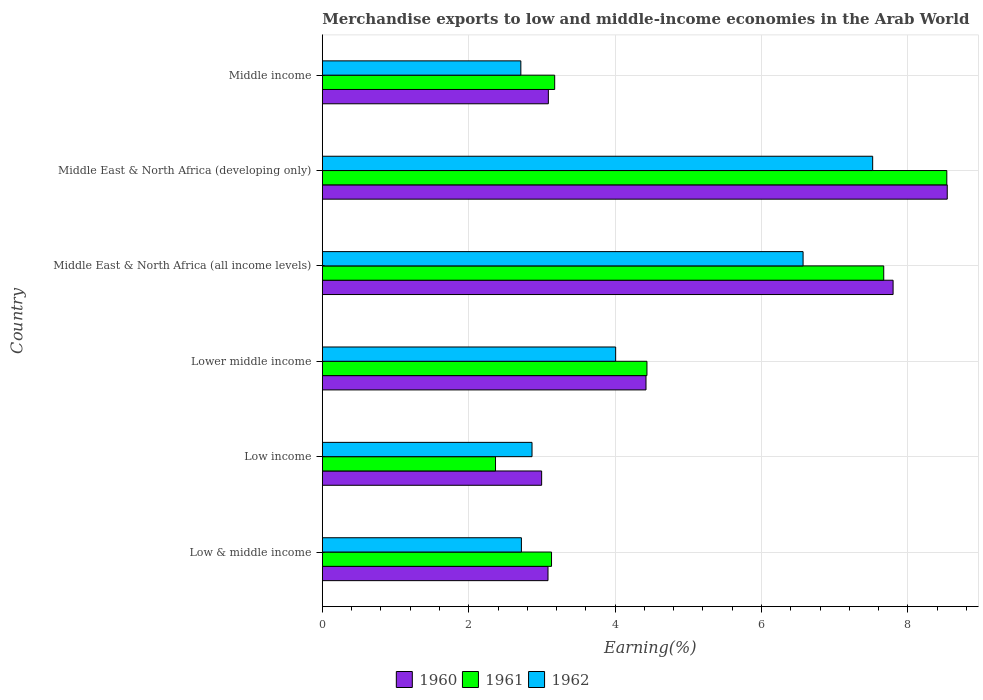Are the number of bars per tick equal to the number of legend labels?
Offer a terse response. Yes. Are the number of bars on each tick of the Y-axis equal?
Your answer should be compact. Yes. How many bars are there on the 3rd tick from the top?
Your answer should be compact. 3. What is the label of the 6th group of bars from the top?
Provide a succinct answer. Low & middle income. In how many cases, is the number of bars for a given country not equal to the number of legend labels?
Your answer should be very brief. 0. What is the percentage of amount earned from merchandise exports in 1960 in Middle income?
Make the answer very short. 3.09. Across all countries, what is the maximum percentage of amount earned from merchandise exports in 1962?
Your answer should be very brief. 7.52. Across all countries, what is the minimum percentage of amount earned from merchandise exports in 1960?
Make the answer very short. 3. In which country was the percentage of amount earned from merchandise exports in 1962 maximum?
Give a very brief answer. Middle East & North Africa (developing only). What is the total percentage of amount earned from merchandise exports in 1962 in the graph?
Provide a succinct answer. 26.39. What is the difference between the percentage of amount earned from merchandise exports in 1960 in Middle East & North Africa (all income levels) and that in Middle East & North Africa (developing only)?
Make the answer very short. -0.74. What is the difference between the percentage of amount earned from merchandise exports in 1961 in Low & middle income and the percentage of amount earned from merchandise exports in 1962 in Low income?
Ensure brevity in your answer.  0.27. What is the average percentage of amount earned from merchandise exports in 1960 per country?
Your answer should be very brief. 4.99. What is the difference between the percentage of amount earned from merchandise exports in 1962 and percentage of amount earned from merchandise exports in 1961 in Middle East & North Africa (developing only)?
Give a very brief answer. -1.01. In how many countries, is the percentage of amount earned from merchandise exports in 1961 greater than 4.4 %?
Offer a terse response. 3. What is the ratio of the percentage of amount earned from merchandise exports in 1961 in Low income to that in Middle East & North Africa (developing only)?
Give a very brief answer. 0.28. Is the percentage of amount earned from merchandise exports in 1961 in Low income less than that in Lower middle income?
Provide a succinct answer. Yes. What is the difference between the highest and the second highest percentage of amount earned from merchandise exports in 1961?
Offer a very short reply. 0.86. What is the difference between the highest and the lowest percentage of amount earned from merchandise exports in 1962?
Provide a short and direct response. 4.81. What does the 2nd bar from the bottom in Middle East & North Africa (developing only) represents?
Make the answer very short. 1961. Is it the case that in every country, the sum of the percentage of amount earned from merchandise exports in 1962 and percentage of amount earned from merchandise exports in 1961 is greater than the percentage of amount earned from merchandise exports in 1960?
Give a very brief answer. Yes. Are all the bars in the graph horizontal?
Keep it short and to the point. Yes. How many countries are there in the graph?
Keep it short and to the point. 6. Are the values on the major ticks of X-axis written in scientific E-notation?
Give a very brief answer. No. How many legend labels are there?
Give a very brief answer. 3. How are the legend labels stacked?
Offer a terse response. Horizontal. What is the title of the graph?
Make the answer very short. Merchandise exports to low and middle-income economies in the Arab World. Does "1982" appear as one of the legend labels in the graph?
Give a very brief answer. No. What is the label or title of the X-axis?
Your response must be concise. Earning(%). What is the Earning(%) in 1960 in Low & middle income?
Make the answer very short. 3.08. What is the Earning(%) of 1961 in Low & middle income?
Make the answer very short. 3.13. What is the Earning(%) in 1962 in Low & middle income?
Give a very brief answer. 2.72. What is the Earning(%) of 1960 in Low income?
Your answer should be very brief. 3. What is the Earning(%) of 1961 in Low income?
Offer a very short reply. 2.37. What is the Earning(%) in 1962 in Low income?
Provide a succinct answer. 2.86. What is the Earning(%) of 1960 in Lower middle income?
Your response must be concise. 4.42. What is the Earning(%) of 1961 in Lower middle income?
Your response must be concise. 4.43. What is the Earning(%) of 1962 in Lower middle income?
Offer a very short reply. 4.01. What is the Earning(%) in 1960 in Middle East & North Africa (all income levels)?
Provide a short and direct response. 7.8. What is the Earning(%) of 1961 in Middle East & North Africa (all income levels)?
Give a very brief answer. 7.67. What is the Earning(%) in 1962 in Middle East & North Africa (all income levels)?
Offer a very short reply. 6.57. What is the Earning(%) in 1960 in Middle East & North Africa (developing only)?
Your answer should be compact. 8.54. What is the Earning(%) in 1961 in Middle East & North Africa (developing only)?
Offer a very short reply. 8.53. What is the Earning(%) of 1962 in Middle East & North Africa (developing only)?
Offer a terse response. 7.52. What is the Earning(%) of 1960 in Middle income?
Your answer should be very brief. 3.09. What is the Earning(%) in 1961 in Middle income?
Give a very brief answer. 3.17. What is the Earning(%) of 1962 in Middle income?
Offer a terse response. 2.71. Across all countries, what is the maximum Earning(%) of 1960?
Offer a very short reply. 8.54. Across all countries, what is the maximum Earning(%) of 1961?
Give a very brief answer. 8.53. Across all countries, what is the maximum Earning(%) in 1962?
Keep it short and to the point. 7.52. Across all countries, what is the minimum Earning(%) in 1960?
Offer a very short reply. 3. Across all countries, what is the minimum Earning(%) in 1961?
Make the answer very short. 2.37. Across all countries, what is the minimum Earning(%) in 1962?
Keep it short and to the point. 2.71. What is the total Earning(%) of 1960 in the graph?
Keep it short and to the point. 29.92. What is the total Earning(%) of 1961 in the graph?
Keep it short and to the point. 29.31. What is the total Earning(%) of 1962 in the graph?
Your answer should be compact. 26.39. What is the difference between the Earning(%) in 1960 in Low & middle income and that in Low income?
Your answer should be compact. 0.09. What is the difference between the Earning(%) in 1961 in Low & middle income and that in Low income?
Your response must be concise. 0.77. What is the difference between the Earning(%) in 1962 in Low & middle income and that in Low income?
Your answer should be very brief. -0.14. What is the difference between the Earning(%) in 1960 in Low & middle income and that in Lower middle income?
Keep it short and to the point. -1.34. What is the difference between the Earning(%) of 1961 in Low & middle income and that in Lower middle income?
Offer a terse response. -1.3. What is the difference between the Earning(%) in 1962 in Low & middle income and that in Lower middle income?
Provide a short and direct response. -1.29. What is the difference between the Earning(%) in 1960 in Low & middle income and that in Middle East & North Africa (all income levels)?
Make the answer very short. -4.71. What is the difference between the Earning(%) in 1961 in Low & middle income and that in Middle East & North Africa (all income levels)?
Your answer should be very brief. -4.54. What is the difference between the Earning(%) in 1962 in Low & middle income and that in Middle East & North Africa (all income levels)?
Ensure brevity in your answer.  -3.85. What is the difference between the Earning(%) in 1960 in Low & middle income and that in Middle East & North Africa (developing only)?
Keep it short and to the point. -5.45. What is the difference between the Earning(%) of 1961 in Low & middle income and that in Middle East & North Africa (developing only)?
Provide a short and direct response. -5.4. What is the difference between the Earning(%) of 1962 in Low & middle income and that in Middle East & North Africa (developing only)?
Make the answer very short. -4.8. What is the difference between the Earning(%) in 1960 in Low & middle income and that in Middle income?
Ensure brevity in your answer.  -0. What is the difference between the Earning(%) in 1961 in Low & middle income and that in Middle income?
Keep it short and to the point. -0.04. What is the difference between the Earning(%) of 1962 in Low & middle income and that in Middle income?
Give a very brief answer. 0.01. What is the difference between the Earning(%) in 1960 in Low income and that in Lower middle income?
Give a very brief answer. -1.43. What is the difference between the Earning(%) of 1961 in Low income and that in Lower middle income?
Provide a succinct answer. -2.07. What is the difference between the Earning(%) of 1962 in Low income and that in Lower middle income?
Provide a short and direct response. -1.14. What is the difference between the Earning(%) in 1960 in Low income and that in Middle East & North Africa (all income levels)?
Offer a terse response. -4.8. What is the difference between the Earning(%) of 1961 in Low income and that in Middle East & North Africa (all income levels)?
Your response must be concise. -5.3. What is the difference between the Earning(%) in 1962 in Low income and that in Middle East & North Africa (all income levels)?
Make the answer very short. -3.7. What is the difference between the Earning(%) in 1960 in Low income and that in Middle East & North Africa (developing only)?
Keep it short and to the point. -5.54. What is the difference between the Earning(%) in 1961 in Low income and that in Middle East & North Africa (developing only)?
Provide a short and direct response. -6.17. What is the difference between the Earning(%) in 1962 in Low income and that in Middle East & North Africa (developing only)?
Your answer should be compact. -4.65. What is the difference between the Earning(%) of 1960 in Low income and that in Middle income?
Offer a terse response. -0.09. What is the difference between the Earning(%) of 1961 in Low income and that in Middle income?
Offer a terse response. -0.81. What is the difference between the Earning(%) of 1962 in Low income and that in Middle income?
Provide a short and direct response. 0.15. What is the difference between the Earning(%) of 1960 in Lower middle income and that in Middle East & North Africa (all income levels)?
Offer a terse response. -3.38. What is the difference between the Earning(%) in 1961 in Lower middle income and that in Middle East & North Africa (all income levels)?
Make the answer very short. -3.23. What is the difference between the Earning(%) in 1962 in Lower middle income and that in Middle East & North Africa (all income levels)?
Your response must be concise. -2.56. What is the difference between the Earning(%) in 1960 in Lower middle income and that in Middle East & North Africa (developing only)?
Your answer should be compact. -4.12. What is the difference between the Earning(%) in 1961 in Lower middle income and that in Middle East & North Africa (developing only)?
Your response must be concise. -4.1. What is the difference between the Earning(%) of 1962 in Lower middle income and that in Middle East & North Africa (developing only)?
Your answer should be very brief. -3.51. What is the difference between the Earning(%) of 1960 in Lower middle income and that in Middle income?
Give a very brief answer. 1.33. What is the difference between the Earning(%) in 1961 in Lower middle income and that in Middle income?
Your response must be concise. 1.26. What is the difference between the Earning(%) in 1962 in Lower middle income and that in Middle income?
Provide a succinct answer. 1.3. What is the difference between the Earning(%) in 1960 in Middle East & North Africa (all income levels) and that in Middle East & North Africa (developing only)?
Your answer should be compact. -0.74. What is the difference between the Earning(%) in 1961 in Middle East & North Africa (all income levels) and that in Middle East & North Africa (developing only)?
Offer a terse response. -0.86. What is the difference between the Earning(%) of 1962 in Middle East & North Africa (all income levels) and that in Middle East & North Africa (developing only)?
Your answer should be compact. -0.95. What is the difference between the Earning(%) in 1960 in Middle East & North Africa (all income levels) and that in Middle income?
Provide a short and direct response. 4.71. What is the difference between the Earning(%) of 1961 in Middle East & North Africa (all income levels) and that in Middle income?
Offer a very short reply. 4.5. What is the difference between the Earning(%) of 1962 in Middle East & North Africa (all income levels) and that in Middle income?
Provide a short and direct response. 3.86. What is the difference between the Earning(%) of 1960 in Middle East & North Africa (developing only) and that in Middle income?
Your answer should be compact. 5.45. What is the difference between the Earning(%) in 1961 in Middle East & North Africa (developing only) and that in Middle income?
Make the answer very short. 5.36. What is the difference between the Earning(%) in 1962 in Middle East & North Africa (developing only) and that in Middle income?
Your answer should be compact. 4.81. What is the difference between the Earning(%) of 1960 in Low & middle income and the Earning(%) of 1961 in Low income?
Your answer should be very brief. 0.72. What is the difference between the Earning(%) of 1960 in Low & middle income and the Earning(%) of 1962 in Low income?
Make the answer very short. 0.22. What is the difference between the Earning(%) in 1961 in Low & middle income and the Earning(%) in 1962 in Low income?
Make the answer very short. 0.27. What is the difference between the Earning(%) of 1960 in Low & middle income and the Earning(%) of 1961 in Lower middle income?
Offer a very short reply. -1.35. What is the difference between the Earning(%) in 1960 in Low & middle income and the Earning(%) in 1962 in Lower middle income?
Offer a very short reply. -0.92. What is the difference between the Earning(%) of 1961 in Low & middle income and the Earning(%) of 1962 in Lower middle income?
Offer a very short reply. -0.88. What is the difference between the Earning(%) in 1960 in Low & middle income and the Earning(%) in 1961 in Middle East & North Africa (all income levels)?
Your answer should be compact. -4.59. What is the difference between the Earning(%) in 1960 in Low & middle income and the Earning(%) in 1962 in Middle East & North Africa (all income levels)?
Ensure brevity in your answer.  -3.48. What is the difference between the Earning(%) in 1961 in Low & middle income and the Earning(%) in 1962 in Middle East & North Africa (all income levels)?
Give a very brief answer. -3.44. What is the difference between the Earning(%) in 1960 in Low & middle income and the Earning(%) in 1961 in Middle East & North Africa (developing only)?
Give a very brief answer. -5.45. What is the difference between the Earning(%) in 1960 in Low & middle income and the Earning(%) in 1962 in Middle East & North Africa (developing only)?
Make the answer very short. -4.44. What is the difference between the Earning(%) of 1961 in Low & middle income and the Earning(%) of 1962 in Middle East & North Africa (developing only)?
Make the answer very short. -4.39. What is the difference between the Earning(%) of 1960 in Low & middle income and the Earning(%) of 1961 in Middle income?
Give a very brief answer. -0.09. What is the difference between the Earning(%) in 1960 in Low & middle income and the Earning(%) in 1962 in Middle income?
Your answer should be compact. 0.37. What is the difference between the Earning(%) of 1961 in Low & middle income and the Earning(%) of 1962 in Middle income?
Make the answer very short. 0.42. What is the difference between the Earning(%) of 1960 in Low income and the Earning(%) of 1961 in Lower middle income?
Keep it short and to the point. -1.44. What is the difference between the Earning(%) of 1960 in Low income and the Earning(%) of 1962 in Lower middle income?
Your answer should be very brief. -1.01. What is the difference between the Earning(%) of 1961 in Low income and the Earning(%) of 1962 in Lower middle income?
Offer a very short reply. -1.64. What is the difference between the Earning(%) of 1960 in Low income and the Earning(%) of 1961 in Middle East & North Africa (all income levels)?
Your answer should be compact. -4.67. What is the difference between the Earning(%) of 1960 in Low income and the Earning(%) of 1962 in Middle East & North Africa (all income levels)?
Keep it short and to the point. -3.57. What is the difference between the Earning(%) in 1961 in Low income and the Earning(%) in 1962 in Middle East & North Africa (all income levels)?
Give a very brief answer. -4.2. What is the difference between the Earning(%) in 1960 in Low income and the Earning(%) in 1961 in Middle East & North Africa (developing only)?
Provide a succinct answer. -5.54. What is the difference between the Earning(%) of 1960 in Low income and the Earning(%) of 1962 in Middle East & North Africa (developing only)?
Offer a terse response. -4.52. What is the difference between the Earning(%) of 1961 in Low income and the Earning(%) of 1962 in Middle East & North Africa (developing only)?
Give a very brief answer. -5.15. What is the difference between the Earning(%) in 1960 in Low income and the Earning(%) in 1961 in Middle income?
Your answer should be very brief. -0.18. What is the difference between the Earning(%) in 1960 in Low income and the Earning(%) in 1962 in Middle income?
Provide a short and direct response. 0.28. What is the difference between the Earning(%) of 1961 in Low income and the Earning(%) of 1962 in Middle income?
Provide a short and direct response. -0.35. What is the difference between the Earning(%) of 1960 in Lower middle income and the Earning(%) of 1961 in Middle East & North Africa (all income levels)?
Keep it short and to the point. -3.25. What is the difference between the Earning(%) in 1960 in Lower middle income and the Earning(%) in 1962 in Middle East & North Africa (all income levels)?
Keep it short and to the point. -2.15. What is the difference between the Earning(%) of 1961 in Lower middle income and the Earning(%) of 1962 in Middle East & North Africa (all income levels)?
Ensure brevity in your answer.  -2.13. What is the difference between the Earning(%) of 1960 in Lower middle income and the Earning(%) of 1961 in Middle East & North Africa (developing only)?
Your answer should be compact. -4.11. What is the difference between the Earning(%) of 1960 in Lower middle income and the Earning(%) of 1962 in Middle East & North Africa (developing only)?
Your answer should be compact. -3.1. What is the difference between the Earning(%) of 1961 in Lower middle income and the Earning(%) of 1962 in Middle East & North Africa (developing only)?
Give a very brief answer. -3.08. What is the difference between the Earning(%) in 1960 in Lower middle income and the Earning(%) in 1961 in Middle income?
Your answer should be compact. 1.25. What is the difference between the Earning(%) in 1960 in Lower middle income and the Earning(%) in 1962 in Middle income?
Offer a very short reply. 1.71. What is the difference between the Earning(%) of 1961 in Lower middle income and the Earning(%) of 1962 in Middle income?
Offer a very short reply. 1.72. What is the difference between the Earning(%) in 1960 in Middle East & North Africa (all income levels) and the Earning(%) in 1961 in Middle East & North Africa (developing only)?
Offer a very short reply. -0.73. What is the difference between the Earning(%) in 1960 in Middle East & North Africa (all income levels) and the Earning(%) in 1962 in Middle East & North Africa (developing only)?
Offer a terse response. 0.28. What is the difference between the Earning(%) in 1961 in Middle East & North Africa (all income levels) and the Earning(%) in 1962 in Middle East & North Africa (developing only)?
Provide a succinct answer. 0.15. What is the difference between the Earning(%) in 1960 in Middle East & North Africa (all income levels) and the Earning(%) in 1961 in Middle income?
Give a very brief answer. 4.62. What is the difference between the Earning(%) in 1960 in Middle East & North Africa (all income levels) and the Earning(%) in 1962 in Middle income?
Keep it short and to the point. 5.09. What is the difference between the Earning(%) of 1961 in Middle East & North Africa (all income levels) and the Earning(%) of 1962 in Middle income?
Your answer should be compact. 4.96. What is the difference between the Earning(%) of 1960 in Middle East & North Africa (developing only) and the Earning(%) of 1961 in Middle income?
Offer a very short reply. 5.36. What is the difference between the Earning(%) of 1960 in Middle East & North Africa (developing only) and the Earning(%) of 1962 in Middle income?
Give a very brief answer. 5.83. What is the difference between the Earning(%) of 1961 in Middle East & North Africa (developing only) and the Earning(%) of 1962 in Middle income?
Give a very brief answer. 5.82. What is the average Earning(%) of 1960 per country?
Make the answer very short. 4.99. What is the average Earning(%) of 1961 per country?
Your answer should be compact. 4.88. What is the average Earning(%) of 1962 per country?
Provide a short and direct response. 4.4. What is the difference between the Earning(%) of 1960 and Earning(%) of 1961 in Low & middle income?
Ensure brevity in your answer.  -0.05. What is the difference between the Earning(%) in 1960 and Earning(%) in 1962 in Low & middle income?
Ensure brevity in your answer.  0.36. What is the difference between the Earning(%) in 1961 and Earning(%) in 1962 in Low & middle income?
Your response must be concise. 0.41. What is the difference between the Earning(%) in 1960 and Earning(%) in 1961 in Low income?
Your answer should be very brief. 0.63. What is the difference between the Earning(%) in 1960 and Earning(%) in 1962 in Low income?
Provide a short and direct response. 0.13. What is the difference between the Earning(%) of 1961 and Earning(%) of 1962 in Low income?
Ensure brevity in your answer.  -0.5. What is the difference between the Earning(%) of 1960 and Earning(%) of 1961 in Lower middle income?
Provide a short and direct response. -0.01. What is the difference between the Earning(%) in 1960 and Earning(%) in 1962 in Lower middle income?
Your answer should be very brief. 0.41. What is the difference between the Earning(%) of 1961 and Earning(%) of 1962 in Lower middle income?
Ensure brevity in your answer.  0.43. What is the difference between the Earning(%) in 1960 and Earning(%) in 1961 in Middle East & North Africa (all income levels)?
Your answer should be very brief. 0.13. What is the difference between the Earning(%) of 1960 and Earning(%) of 1962 in Middle East & North Africa (all income levels)?
Make the answer very short. 1.23. What is the difference between the Earning(%) in 1961 and Earning(%) in 1962 in Middle East & North Africa (all income levels)?
Keep it short and to the point. 1.1. What is the difference between the Earning(%) of 1960 and Earning(%) of 1961 in Middle East & North Africa (developing only)?
Your response must be concise. 0.01. What is the difference between the Earning(%) of 1960 and Earning(%) of 1962 in Middle East & North Africa (developing only)?
Provide a short and direct response. 1.02. What is the difference between the Earning(%) of 1961 and Earning(%) of 1962 in Middle East & North Africa (developing only)?
Offer a very short reply. 1.01. What is the difference between the Earning(%) in 1960 and Earning(%) in 1961 in Middle income?
Your answer should be compact. -0.09. What is the difference between the Earning(%) of 1960 and Earning(%) of 1962 in Middle income?
Give a very brief answer. 0.38. What is the difference between the Earning(%) in 1961 and Earning(%) in 1962 in Middle income?
Provide a short and direct response. 0.46. What is the ratio of the Earning(%) in 1961 in Low & middle income to that in Low income?
Your response must be concise. 1.32. What is the ratio of the Earning(%) in 1962 in Low & middle income to that in Low income?
Offer a very short reply. 0.95. What is the ratio of the Earning(%) of 1960 in Low & middle income to that in Lower middle income?
Keep it short and to the point. 0.7. What is the ratio of the Earning(%) in 1961 in Low & middle income to that in Lower middle income?
Your response must be concise. 0.71. What is the ratio of the Earning(%) of 1962 in Low & middle income to that in Lower middle income?
Your response must be concise. 0.68. What is the ratio of the Earning(%) of 1960 in Low & middle income to that in Middle East & North Africa (all income levels)?
Give a very brief answer. 0.4. What is the ratio of the Earning(%) of 1961 in Low & middle income to that in Middle East & North Africa (all income levels)?
Your answer should be very brief. 0.41. What is the ratio of the Earning(%) of 1962 in Low & middle income to that in Middle East & North Africa (all income levels)?
Make the answer very short. 0.41. What is the ratio of the Earning(%) in 1960 in Low & middle income to that in Middle East & North Africa (developing only)?
Your response must be concise. 0.36. What is the ratio of the Earning(%) of 1961 in Low & middle income to that in Middle East & North Africa (developing only)?
Offer a terse response. 0.37. What is the ratio of the Earning(%) of 1962 in Low & middle income to that in Middle East & North Africa (developing only)?
Your answer should be very brief. 0.36. What is the ratio of the Earning(%) of 1961 in Low & middle income to that in Middle income?
Ensure brevity in your answer.  0.99. What is the ratio of the Earning(%) in 1962 in Low & middle income to that in Middle income?
Ensure brevity in your answer.  1. What is the ratio of the Earning(%) of 1960 in Low income to that in Lower middle income?
Make the answer very short. 0.68. What is the ratio of the Earning(%) of 1961 in Low income to that in Lower middle income?
Provide a short and direct response. 0.53. What is the ratio of the Earning(%) of 1962 in Low income to that in Lower middle income?
Give a very brief answer. 0.71. What is the ratio of the Earning(%) in 1960 in Low income to that in Middle East & North Africa (all income levels)?
Give a very brief answer. 0.38. What is the ratio of the Earning(%) of 1961 in Low income to that in Middle East & North Africa (all income levels)?
Keep it short and to the point. 0.31. What is the ratio of the Earning(%) in 1962 in Low income to that in Middle East & North Africa (all income levels)?
Your answer should be very brief. 0.44. What is the ratio of the Earning(%) of 1960 in Low income to that in Middle East & North Africa (developing only)?
Give a very brief answer. 0.35. What is the ratio of the Earning(%) in 1961 in Low income to that in Middle East & North Africa (developing only)?
Ensure brevity in your answer.  0.28. What is the ratio of the Earning(%) of 1962 in Low income to that in Middle East & North Africa (developing only)?
Offer a terse response. 0.38. What is the ratio of the Earning(%) of 1960 in Low income to that in Middle income?
Make the answer very short. 0.97. What is the ratio of the Earning(%) of 1961 in Low income to that in Middle income?
Your response must be concise. 0.75. What is the ratio of the Earning(%) of 1962 in Low income to that in Middle income?
Your response must be concise. 1.06. What is the ratio of the Earning(%) in 1960 in Lower middle income to that in Middle East & North Africa (all income levels)?
Keep it short and to the point. 0.57. What is the ratio of the Earning(%) of 1961 in Lower middle income to that in Middle East & North Africa (all income levels)?
Your answer should be compact. 0.58. What is the ratio of the Earning(%) of 1962 in Lower middle income to that in Middle East & North Africa (all income levels)?
Offer a terse response. 0.61. What is the ratio of the Earning(%) of 1960 in Lower middle income to that in Middle East & North Africa (developing only)?
Offer a very short reply. 0.52. What is the ratio of the Earning(%) of 1961 in Lower middle income to that in Middle East & North Africa (developing only)?
Provide a short and direct response. 0.52. What is the ratio of the Earning(%) of 1962 in Lower middle income to that in Middle East & North Africa (developing only)?
Provide a short and direct response. 0.53. What is the ratio of the Earning(%) in 1960 in Lower middle income to that in Middle income?
Make the answer very short. 1.43. What is the ratio of the Earning(%) in 1961 in Lower middle income to that in Middle income?
Make the answer very short. 1.4. What is the ratio of the Earning(%) in 1962 in Lower middle income to that in Middle income?
Keep it short and to the point. 1.48. What is the ratio of the Earning(%) in 1960 in Middle East & North Africa (all income levels) to that in Middle East & North Africa (developing only)?
Provide a succinct answer. 0.91. What is the ratio of the Earning(%) of 1961 in Middle East & North Africa (all income levels) to that in Middle East & North Africa (developing only)?
Keep it short and to the point. 0.9. What is the ratio of the Earning(%) of 1962 in Middle East & North Africa (all income levels) to that in Middle East & North Africa (developing only)?
Keep it short and to the point. 0.87. What is the ratio of the Earning(%) of 1960 in Middle East & North Africa (all income levels) to that in Middle income?
Your response must be concise. 2.53. What is the ratio of the Earning(%) of 1961 in Middle East & North Africa (all income levels) to that in Middle income?
Provide a succinct answer. 2.42. What is the ratio of the Earning(%) in 1962 in Middle East & North Africa (all income levels) to that in Middle income?
Your response must be concise. 2.42. What is the ratio of the Earning(%) in 1960 in Middle East & North Africa (developing only) to that in Middle income?
Your answer should be compact. 2.76. What is the ratio of the Earning(%) of 1961 in Middle East & North Africa (developing only) to that in Middle income?
Offer a very short reply. 2.69. What is the ratio of the Earning(%) of 1962 in Middle East & North Africa (developing only) to that in Middle income?
Your answer should be compact. 2.77. What is the difference between the highest and the second highest Earning(%) in 1960?
Your response must be concise. 0.74. What is the difference between the highest and the second highest Earning(%) of 1961?
Provide a succinct answer. 0.86. What is the difference between the highest and the second highest Earning(%) in 1962?
Make the answer very short. 0.95. What is the difference between the highest and the lowest Earning(%) in 1960?
Give a very brief answer. 5.54. What is the difference between the highest and the lowest Earning(%) of 1961?
Offer a very short reply. 6.17. What is the difference between the highest and the lowest Earning(%) in 1962?
Give a very brief answer. 4.81. 